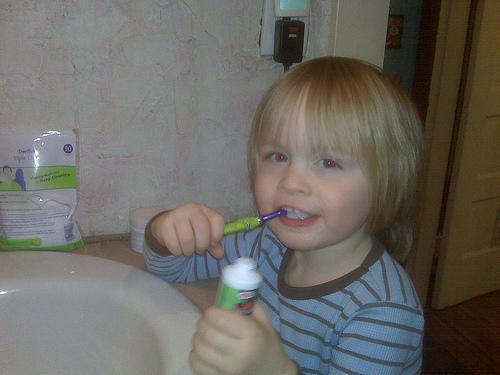How many toothbrushes are there?
Give a very brief answer. 1. 